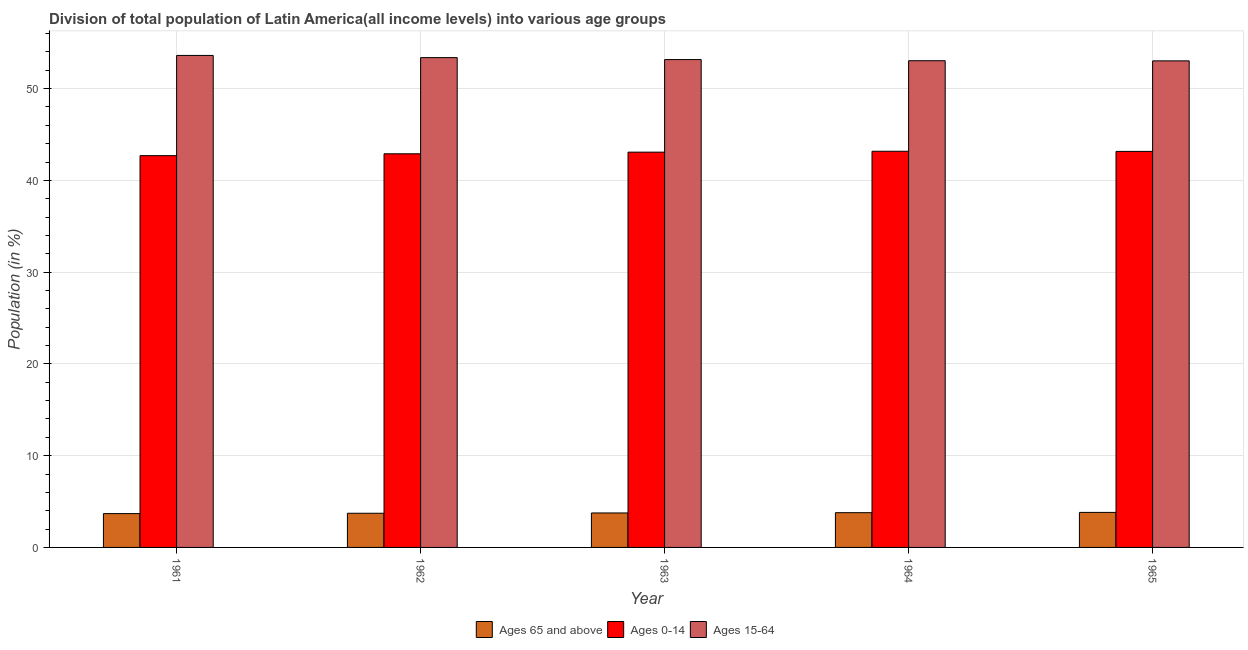How many different coloured bars are there?
Offer a terse response. 3. Are the number of bars per tick equal to the number of legend labels?
Make the answer very short. Yes. What is the label of the 1st group of bars from the left?
Make the answer very short. 1961. In how many cases, is the number of bars for a given year not equal to the number of legend labels?
Keep it short and to the point. 0. What is the percentage of population within the age-group 15-64 in 1961?
Ensure brevity in your answer.  53.62. Across all years, what is the maximum percentage of population within the age-group 15-64?
Keep it short and to the point. 53.62. Across all years, what is the minimum percentage of population within the age-group 15-64?
Your answer should be compact. 53.03. In which year was the percentage of population within the age-group 15-64 minimum?
Offer a terse response. 1965. What is the total percentage of population within the age-group 0-14 in the graph?
Your answer should be very brief. 215. What is the difference between the percentage of population within the age-group 15-64 in 1961 and that in 1965?
Offer a very short reply. 0.59. What is the difference between the percentage of population within the age-group 0-14 in 1963 and the percentage of population within the age-group 15-64 in 1965?
Make the answer very short. -0.08. What is the average percentage of population within the age-group 0-14 per year?
Provide a short and direct response. 43. In the year 1962, what is the difference between the percentage of population within the age-group 15-64 and percentage of population within the age-group of 65 and above?
Provide a short and direct response. 0. What is the ratio of the percentage of population within the age-group of 65 and above in 1961 to that in 1964?
Provide a short and direct response. 0.97. What is the difference between the highest and the second highest percentage of population within the age-group of 65 and above?
Make the answer very short. 0.03. What is the difference between the highest and the lowest percentage of population within the age-group 15-64?
Provide a short and direct response. 0.59. In how many years, is the percentage of population within the age-group of 65 and above greater than the average percentage of population within the age-group of 65 and above taken over all years?
Your answer should be very brief. 3. What does the 2nd bar from the left in 1963 represents?
Offer a very short reply. Ages 0-14. What does the 3rd bar from the right in 1965 represents?
Give a very brief answer. Ages 65 and above. How many years are there in the graph?
Offer a very short reply. 5. Does the graph contain any zero values?
Your answer should be compact. No. Does the graph contain grids?
Your response must be concise. Yes. How many legend labels are there?
Provide a short and direct response. 3. What is the title of the graph?
Ensure brevity in your answer.  Division of total population of Latin America(all income levels) into various age groups
. Does "Social Protection and Labor" appear as one of the legend labels in the graph?
Make the answer very short. No. What is the label or title of the X-axis?
Give a very brief answer. Year. What is the label or title of the Y-axis?
Make the answer very short. Population (in %). What is the Population (in %) of Ages 65 and above in 1961?
Offer a terse response. 3.69. What is the Population (in %) in Ages 0-14 in 1961?
Your response must be concise. 42.7. What is the Population (in %) of Ages 15-64 in 1961?
Make the answer very short. 53.62. What is the Population (in %) of Ages 65 and above in 1962?
Make the answer very short. 3.72. What is the Population (in %) in Ages 0-14 in 1962?
Ensure brevity in your answer.  42.9. What is the Population (in %) of Ages 15-64 in 1962?
Your answer should be compact. 53.38. What is the Population (in %) in Ages 65 and above in 1963?
Your answer should be very brief. 3.76. What is the Population (in %) in Ages 0-14 in 1963?
Offer a very short reply. 43.08. What is the Population (in %) in Ages 15-64 in 1963?
Give a very brief answer. 53.17. What is the Population (in %) of Ages 65 and above in 1964?
Keep it short and to the point. 3.79. What is the Population (in %) in Ages 0-14 in 1964?
Ensure brevity in your answer.  43.17. What is the Population (in %) in Ages 15-64 in 1964?
Your answer should be very brief. 53.04. What is the Population (in %) in Ages 65 and above in 1965?
Provide a succinct answer. 3.82. What is the Population (in %) of Ages 0-14 in 1965?
Provide a short and direct response. 43.16. What is the Population (in %) in Ages 15-64 in 1965?
Ensure brevity in your answer.  53.03. Across all years, what is the maximum Population (in %) in Ages 65 and above?
Give a very brief answer. 3.82. Across all years, what is the maximum Population (in %) of Ages 0-14?
Ensure brevity in your answer.  43.17. Across all years, what is the maximum Population (in %) of Ages 15-64?
Give a very brief answer. 53.62. Across all years, what is the minimum Population (in %) in Ages 65 and above?
Offer a terse response. 3.69. Across all years, what is the minimum Population (in %) in Ages 0-14?
Provide a short and direct response. 42.7. Across all years, what is the minimum Population (in %) of Ages 15-64?
Your answer should be compact. 53.03. What is the total Population (in %) of Ages 65 and above in the graph?
Provide a succinct answer. 18.77. What is the total Population (in %) in Ages 0-14 in the graph?
Keep it short and to the point. 215. What is the total Population (in %) in Ages 15-64 in the graph?
Ensure brevity in your answer.  266.23. What is the difference between the Population (in %) of Ages 65 and above in 1961 and that in 1962?
Your response must be concise. -0.04. What is the difference between the Population (in %) of Ages 0-14 in 1961 and that in 1962?
Make the answer very short. -0.2. What is the difference between the Population (in %) in Ages 15-64 in 1961 and that in 1962?
Give a very brief answer. 0.24. What is the difference between the Population (in %) in Ages 65 and above in 1961 and that in 1963?
Make the answer very short. -0.07. What is the difference between the Population (in %) of Ages 0-14 in 1961 and that in 1963?
Provide a short and direct response. -0.38. What is the difference between the Population (in %) in Ages 15-64 in 1961 and that in 1963?
Your answer should be compact. 0.45. What is the difference between the Population (in %) of Ages 65 and above in 1961 and that in 1964?
Provide a short and direct response. -0.1. What is the difference between the Population (in %) in Ages 0-14 in 1961 and that in 1964?
Give a very brief answer. -0.48. What is the difference between the Population (in %) of Ages 15-64 in 1961 and that in 1964?
Ensure brevity in your answer.  0.58. What is the difference between the Population (in %) in Ages 65 and above in 1961 and that in 1965?
Keep it short and to the point. -0.13. What is the difference between the Population (in %) of Ages 0-14 in 1961 and that in 1965?
Offer a very short reply. -0.46. What is the difference between the Population (in %) of Ages 15-64 in 1961 and that in 1965?
Provide a short and direct response. 0.59. What is the difference between the Population (in %) of Ages 65 and above in 1962 and that in 1963?
Your answer should be very brief. -0.03. What is the difference between the Population (in %) in Ages 0-14 in 1962 and that in 1963?
Provide a succinct answer. -0.18. What is the difference between the Population (in %) in Ages 15-64 in 1962 and that in 1963?
Your answer should be very brief. 0.21. What is the difference between the Population (in %) in Ages 65 and above in 1962 and that in 1964?
Provide a succinct answer. -0.06. What is the difference between the Population (in %) of Ages 0-14 in 1962 and that in 1964?
Offer a terse response. -0.28. What is the difference between the Population (in %) of Ages 15-64 in 1962 and that in 1964?
Your answer should be compact. 0.34. What is the difference between the Population (in %) in Ages 65 and above in 1962 and that in 1965?
Make the answer very short. -0.09. What is the difference between the Population (in %) of Ages 0-14 in 1962 and that in 1965?
Keep it short and to the point. -0.26. What is the difference between the Population (in %) of Ages 15-64 in 1962 and that in 1965?
Offer a terse response. 0.35. What is the difference between the Population (in %) of Ages 65 and above in 1963 and that in 1964?
Provide a short and direct response. -0.03. What is the difference between the Population (in %) in Ages 0-14 in 1963 and that in 1964?
Your response must be concise. -0.1. What is the difference between the Population (in %) of Ages 15-64 in 1963 and that in 1964?
Keep it short and to the point. 0.13. What is the difference between the Population (in %) of Ages 65 and above in 1963 and that in 1965?
Ensure brevity in your answer.  -0.06. What is the difference between the Population (in %) in Ages 0-14 in 1963 and that in 1965?
Offer a very short reply. -0.08. What is the difference between the Population (in %) in Ages 15-64 in 1963 and that in 1965?
Provide a short and direct response. 0.14. What is the difference between the Population (in %) of Ages 65 and above in 1964 and that in 1965?
Offer a very short reply. -0.03. What is the difference between the Population (in %) of Ages 0-14 in 1964 and that in 1965?
Make the answer very short. 0.02. What is the difference between the Population (in %) in Ages 15-64 in 1964 and that in 1965?
Offer a terse response. 0.01. What is the difference between the Population (in %) of Ages 65 and above in 1961 and the Population (in %) of Ages 0-14 in 1962?
Offer a terse response. -39.21. What is the difference between the Population (in %) in Ages 65 and above in 1961 and the Population (in %) in Ages 15-64 in 1962?
Offer a very short reply. -49.69. What is the difference between the Population (in %) of Ages 0-14 in 1961 and the Population (in %) of Ages 15-64 in 1962?
Your answer should be compact. -10.68. What is the difference between the Population (in %) in Ages 65 and above in 1961 and the Population (in %) in Ages 0-14 in 1963?
Provide a short and direct response. -39.39. What is the difference between the Population (in %) of Ages 65 and above in 1961 and the Population (in %) of Ages 15-64 in 1963?
Make the answer very short. -49.48. What is the difference between the Population (in %) of Ages 0-14 in 1961 and the Population (in %) of Ages 15-64 in 1963?
Your answer should be compact. -10.47. What is the difference between the Population (in %) of Ages 65 and above in 1961 and the Population (in %) of Ages 0-14 in 1964?
Give a very brief answer. -39.49. What is the difference between the Population (in %) in Ages 65 and above in 1961 and the Population (in %) in Ages 15-64 in 1964?
Offer a terse response. -49.35. What is the difference between the Population (in %) of Ages 0-14 in 1961 and the Population (in %) of Ages 15-64 in 1964?
Offer a terse response. -10.34. What is the difference between the Population (in %) in Ages 65 and above in 1961 and the Population (in %) in Ages 0-14 in 1965?
Offer a terse response. -39.47. What is the difference between the Population (in %) of Ages 65 and above in 1961 and the Population (in %) of Ages 15-64 in 1965?
Your response must be concise. -49.34. What is the difference between the Population (in %) of Ages 0-14 in 1961 and the Population (in %) of Ages 15-64 in 1965?
Offer a terse response. -10.33. What is the difference between the Population (in %) in Ages 65 and above in 1962 and the Population (in %) in Ages 0-14 in 1963?
Provide a succinct answer. -39.35. What is the difference between the Population (in %) in Ages 65 and above in 1962 and the Population (in %) in Ages 15-64 in 1963?
Your answer should be compact. -49.44. What is the difference between the Population (in %) of Ages 0-14 in 1962 and the Population (in %) of Ages 15-64 in 1963?
Your answer should be very brief. -10.27. What is the difference between the Population (in %) of Ages 65 and above in 1962 and the Population (in %) of Ages 0-14 in 1964?
Offer a very short reply. -39.45. What is the difference between the Population (in %) of Ages 65 and above in 1962 and the Population (in %) of Ages 15-64 in 1964?
Offer a terse response. -49.32. What is the difference between the Population (in %) in Ages 0-14 in 1962 and the Population (in %) in Ages 15-64 in 1964?
Ensure brevity in your answer.  -10.14. What is the difference between the Population (in %) in Ages 65 and above in 1962 and the Population (in %) in Ages 0-14 in 1965?
Give a very brief answer. -39.43. What is the difference between the Population (in %) of Ages 65 and above in 1962 and the Population (in %) of Ages 15-64 in 1965?
Your answer should be compact. -49.3. What is the difference between the Population (in %) of Ages 0-14 in 1962 and the Population (in %) of Ages 15-64 in 1965?
Your response must be concise. -10.13. What is the difference between the Population (in %) in Ages 65 and above in 1963 and the Population (in %) in Ages 0-14 in 1964?
Make the answer very short. -39.42. What is the difference between the Population (in %) of Ages 65 and above in 1963 and the Population (in %) of Ages 15-64 in 1964?
Ensure brevity in your answer.  -49.28. What is the difference between the Population (in %) in Ages 0-14 in 1963 and the Population (in %) in Ages 15-64 in 1964?
Offer a terse response. -9.96. What is the difference between the Population (in %) in Ages 65 and above in 1963 and the Population (in %) in Ages 0-14 in 1965?
Offer a terse response. -39.4. What is the difference between the Population (in %) of Ages 65 and above in 1963 and the Population (in %) of Ages 15-64 in 1965?
Give a very brief answer. -49.27. What is the difference between the Population (in %) of Ages 0-14 in 1963 and the Population (in %) of Ages 15-64 in 1965?
Your answer should be compact. -9.95. What is the difference between the Population (in %) of Ages 65 and above in 1964 and the Population (in %) of Ages 0-14 in 1965?
Make the answer very short. -39.37. What is the difference between the Population (in %) of Ages 65 and above in 1964 and the Population (in %) of Ages 15-64 in 1965?
Offer a terse response. -49.24. What is the difference between the Population (in %) in Ages 0-14 in 1964 and the Population (in %) in Ages 15-64 in 1965?
Offer a terse response. -9.85. What is the average Population (in %) of Ages 65 and above per year?
Ensure brevity in your answer.  3.75. What is the average Population (in %) in Ages 0-14 per year?
Ensure brevity in your answer.  43. What is the average Population (in %) of Ages 15-64 per year?
Ensure brevity in your answer.  53.25. In the year 1961, what is the difference between the Population (in %) in Ages 65 and above and Population (in %) in Ages 0-14?
Give a very brief answer. -39.01. In the year 1961, what is the difference between the Population (in %) in Ages 65 and above and Population (in %) in Ages 15-64?
Ensure brevity in your answer.  -49.93. In the year 1961, what is the difference between the Population (in %) of Ages 0-14 and Population (in %) of Ages 15-64?
Keep it short and to the point. -10.92. In the year 1962, what is the difference between the Population (in %) of Ages 65 and above and Population (in %) of Ages 0-14?
Give a very brief answer. -39.17. In the year 1962, what is the difference between the Population (in %) of Ages 65 and above and Population (in %) of Ages 15-64?
Give a very brief answer. -49.65. In the year 1962, what is the difference between the Population (in %) in Ages 0-14 and Population (in %) in Ages 15-64?
Offer a very short reply. -10.48. In the year 1963, what is the difference between the Population (in %) in Ages 65 and above and Population (in %) in Ages 0-14?
Your response must be concise. -39.32. In the year 1963, what is the difference between the Population (in %) of Ages 65 and above and Population (in %) of Ages 15-64?
Ensure brevity in your answer.  -49.41. In the year 1963, what is the difference between the Population (in %) in Ages 0-14 and Population (in %) in Ages 15-64?
Ensure brevity in your answer.  -10.09. In the year 1964, what is the difference between the Population (in %) in Ages 65 and above and Population (in %) in Ages 0-14?
Give a very brief answer. -39.39. In the year 1964, what is the difference between the Population (in %) of Ages 65 and above and Population (in %) of Ages 15-64?
Give a very brief answer. -49.25. In the year 1964, what is the difference between the Population (in %) of Ages 0-14 and Population (in %) of Ages 15-64?
Your answer should be compact. -9.87. In the year 1965, what is the difference between the Population (in %) of Ages 65 and above and Population (in %) of Ages 0-14?
Offer a very short reply. -39.34. In the year 1965, what is the difference between the Population (in %) in Ages 65 and above and Population (in %) in Ages 15-64?
Keep it short and to the point. -49.21. In the year 1965, what is the difference between the Population (in %) in Ages 0-14 and Population (in %) in Ages 15-64?
Offer a terse response. -9.87. What is the ratio of the Population (in %) in Ages 65 and above in 1961 to that in 1963?
Offer a very short reply. 0.98. What is the ratio of the Population (in %) in Ages 0-14 in 1961 to that in 1963?
Offer a very short reply. 0.99. What is the ratio of the Population (in %) in Ages 15-64 in 1961 to that in 1963?
Provide a succinct answer. 1.01. What is the ratio of the Population (in %) of Ages 65 and above in 1961 to that in 1964?
Keep it short and to the point. 0.97. What is the ratio of the Population (in %) of Ages 0-14 in 1961 to that in 1964?
Provide a short and direct response. 0.99. What is the ratio of the Population (in %) in Ages 15-64 in 1961 to that in 1964?
Your response must be concise. 1.01. What is the ratio of the Population (in %) in Ages 0-14 in 1961 to that in 1965?
Offer a very short reply. 0.99. What is the ratio of the Population (in %) of Ages 15-64 in 1961 to that in 1965?
Make the answer very short. 1.01. What is the ratio of the Population (in %) of Ages 0-14 in 1962 to that in 1963?
Your answer should be compact. 1. What is the ratio of the Population (in %) in Ages 15-64 in 1962 to that in 1963?
Your answer should be compact. 1. What is the ratio of the Population (in %) of Ages 65 and above in 1962 to that in 1964?
Offer a terse response. 0.98. What is the ratio of the Population (in %) of Ages 15-64 in 1962 to that in 1964?
Give a very brief answer. 1.01. What is the ratio of the Population (in %) in Ages 65 and above in 1962 to that in 1965?
Your response must be concise. 0.98. What is the ratio of the Population (in %) of Ages 0-14 in 1962 to that in 1965?
Provide a succinct answer. 0.99. What is the ratio of the Population (in %) of Ages 15-64 in 1962 to that in 1965?
Your response must be concise. 1.01. What is the ratio of the Population (in %) of Ages 0-14 in 1963 to that in 1964?
Your answer should be very brief. 1. What is the ratio of the Population (in %) in Ages 15-64 in 1963 to that in 1964?
Your response must be concise. 1. What is the ratio of the Population (in %) in Ages 65 and above in 1963 to that in 1965?
Offer a very short reply. 0.98. What is the ratio of the Population (in %) of Ages 0-14 in 1964 to that in 1965?
Ensure brevity in your answer.  1. What is the ratio of the Population (in %) in Ages 15-64 in 1964 to that in 1965?
Your answer should be very brief. 1. What is the difference between the highest and the second highest Population (in %) of Ages 65 and above?
Offer a very short reply. 0.03. What is the difference between the highest and the second highest Population (in %) in Ages 0-14?
Make the answer very short. 0.02. What is the difference between the highest and the second highest Population (in %) in Ages 15-64?
Offer a terse response. 0.24. What is the difference between the highest and the lowest Population (in %) in Ages 65 and above?
Your answer should be very brief. 0.13. What is the difference between the highest and the lowest Population (in %) in Ages 0-14?
Give a very brief answer. 0.48. What is the difference between the highest and the lowest Population (in %) in Ages 15-64?
Offer a very short reply. 0.59. 